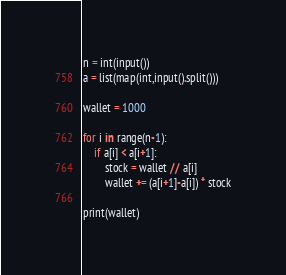<code> <loc_0><loc_0><loc_500><loc_500><_Python_>n = int(input())
a = list(map(int,input().split()))

wallet = 1000

for i in range(n-1):
    if a[i] < a[i+1]:
        stock = wallet // a[i]
        wallet += (a[i+1]-a[i]) * stock

print(wallet)</code> 